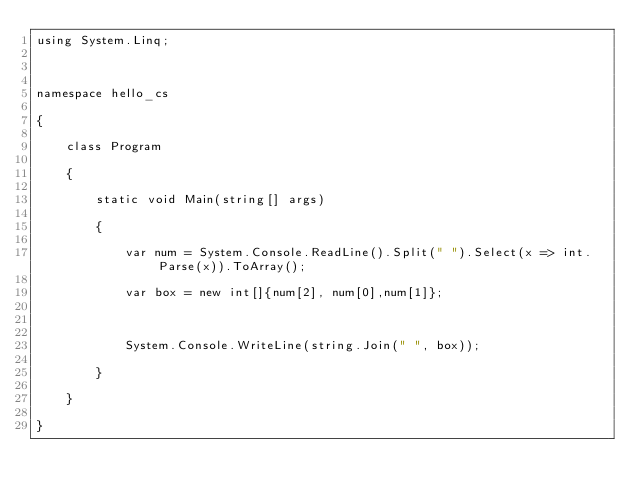Convert code to text. <code><loc_0><loc_0><loc_500><loc_500><_C#_>using System.Linq;



namespace hello_cs

{

    class Program

    {

        static void Main(string[] args)

        {

            var num = System.Console.ReadLine().Split(" ").Select(x => int.Parse(x)).ToArray();

            var box = new int[]{num[2], num[0],num[1]};



            System.Console.WriteLine(string.Join(" ", box));

        }

    }

}

</code> 